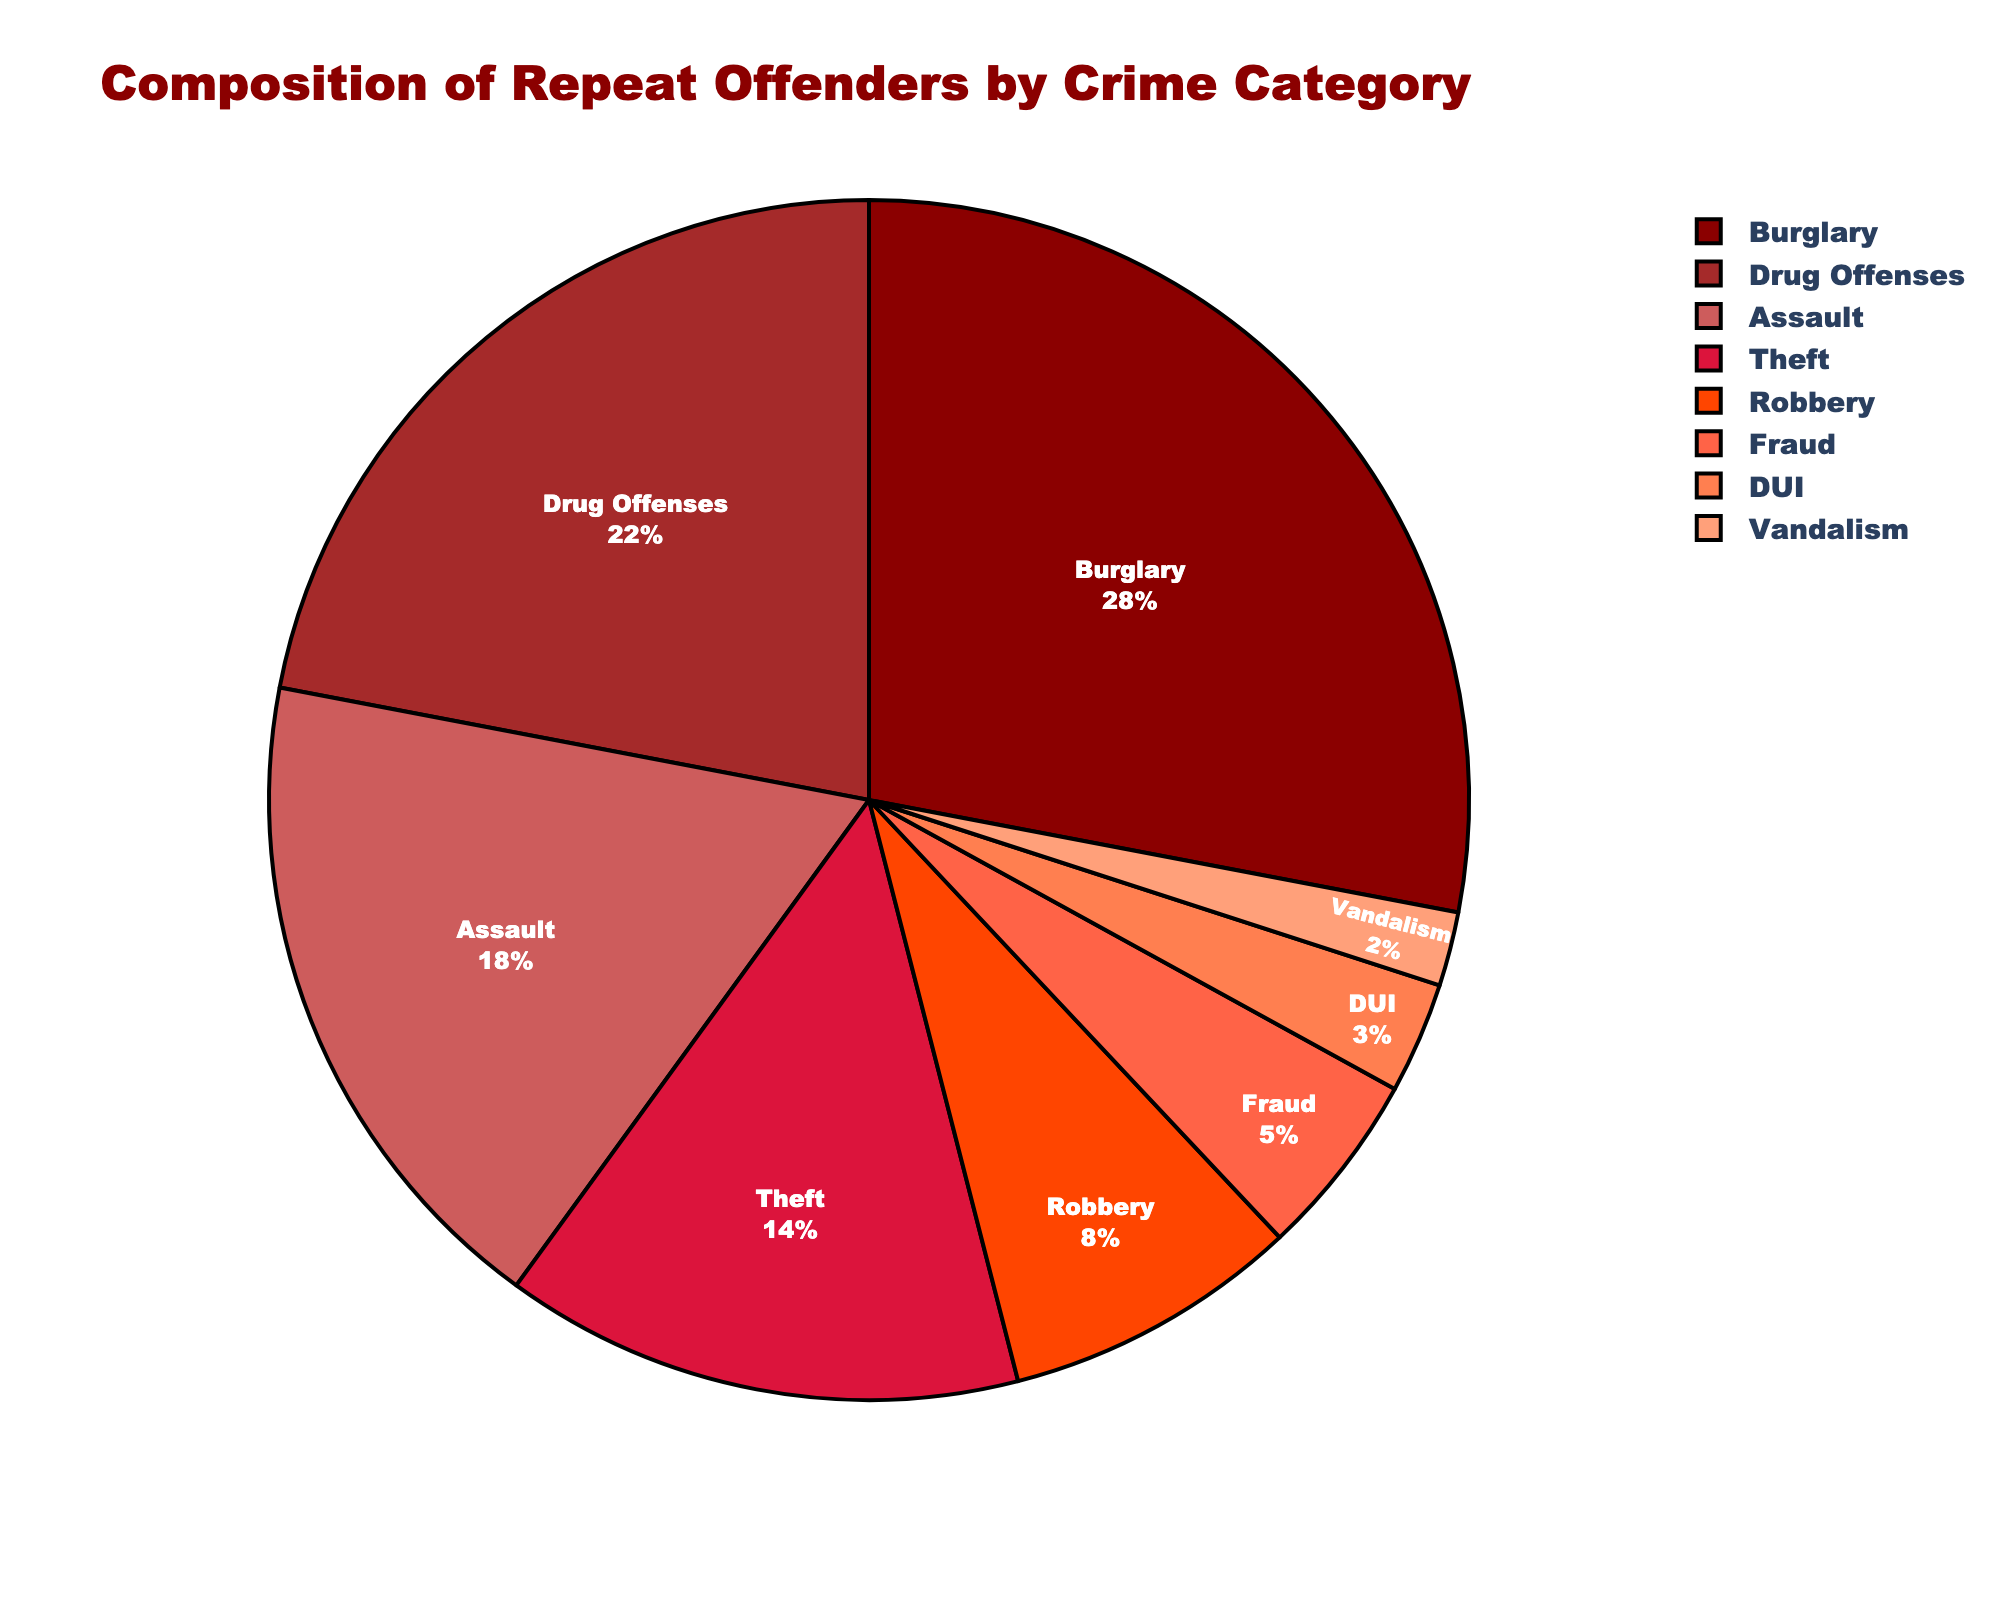Which crime category has the highest percentage of repeat offenders? By looking at the chart, the crime category with the largest segment should be identified. The largest slice is indicated by its visual dominance in size.
Answer: Burglary What is the combined percentage of repeat offenders for Burglary and Drug Offenses? Sum the percentages associated with Burglary (28%) and Drug Offenses (22%). Calculation: 28 + 22 = 50
Answer: 50% Is the percentage of repeat offenders for Assault greater than the percentage for Robbery? Compare the percentages for Assault (18%) and Robbery (8%). Since 18 is greater than 8, the percentage for Assault is higher.
Answer: Yes How much lower is the percentage of repeat offenders for Fraud compared to Theft? Subtract the percentage for Fraud (5%) from the percentage for Theft (14%). Calculation: 14 - 5 = 9
Answer: 9% What is the percentage difference between DUI and Vandalism? Subtract the percentage of Vandalism (2%) from DUI (3%). Calculation: 3 - 2 = 1
Answer: 1% Which categories combined make up more than 50% of repeat offenders? Identify the categories from highest to lowest until their combined percentage exceeds 50%. Adding Burglary (28%) and Drug Offenses (22%) gives 50%, which illustrates the threshold. Any further addition would exceed 50%.
Answer: Burglary and Drug Offenses How does the percentage of repeat offenders compare between Theft and Drug Offenses? Compare the percentages: Drug Offenses at 22% and Theft at 14%. Since 22 is greater than 14, Drug Offenses have a higher percentage.
Answer: Drug Offenses are higher What are the total percentages of the least represented categories (Fraud, DUI, Vandalism)? Sum the percentages of the least represented categories: Fraud (5%), DUI (3%), and Vandalism (2%). Calculation: 5 + 3 + 2 = 10
Answer: 10% Visually, which crime category has the smallest pie slice? Identify the smallest pie slice by size on the chart, which is represented by Vandalism at 2%.
Answer: Vandalism Does Robbery account for more repeat offenders than Fraud, DUI, and Vandalism combined? Compare Robbery's percentage (8%) with the sum of Fraud (5%), DUI (3%), and Vandalism (2%). Calculation: 5 + 3 + 2 = 10. Since 10 is larger than 8, Robbery does not account for more offenders.
Answer: No 